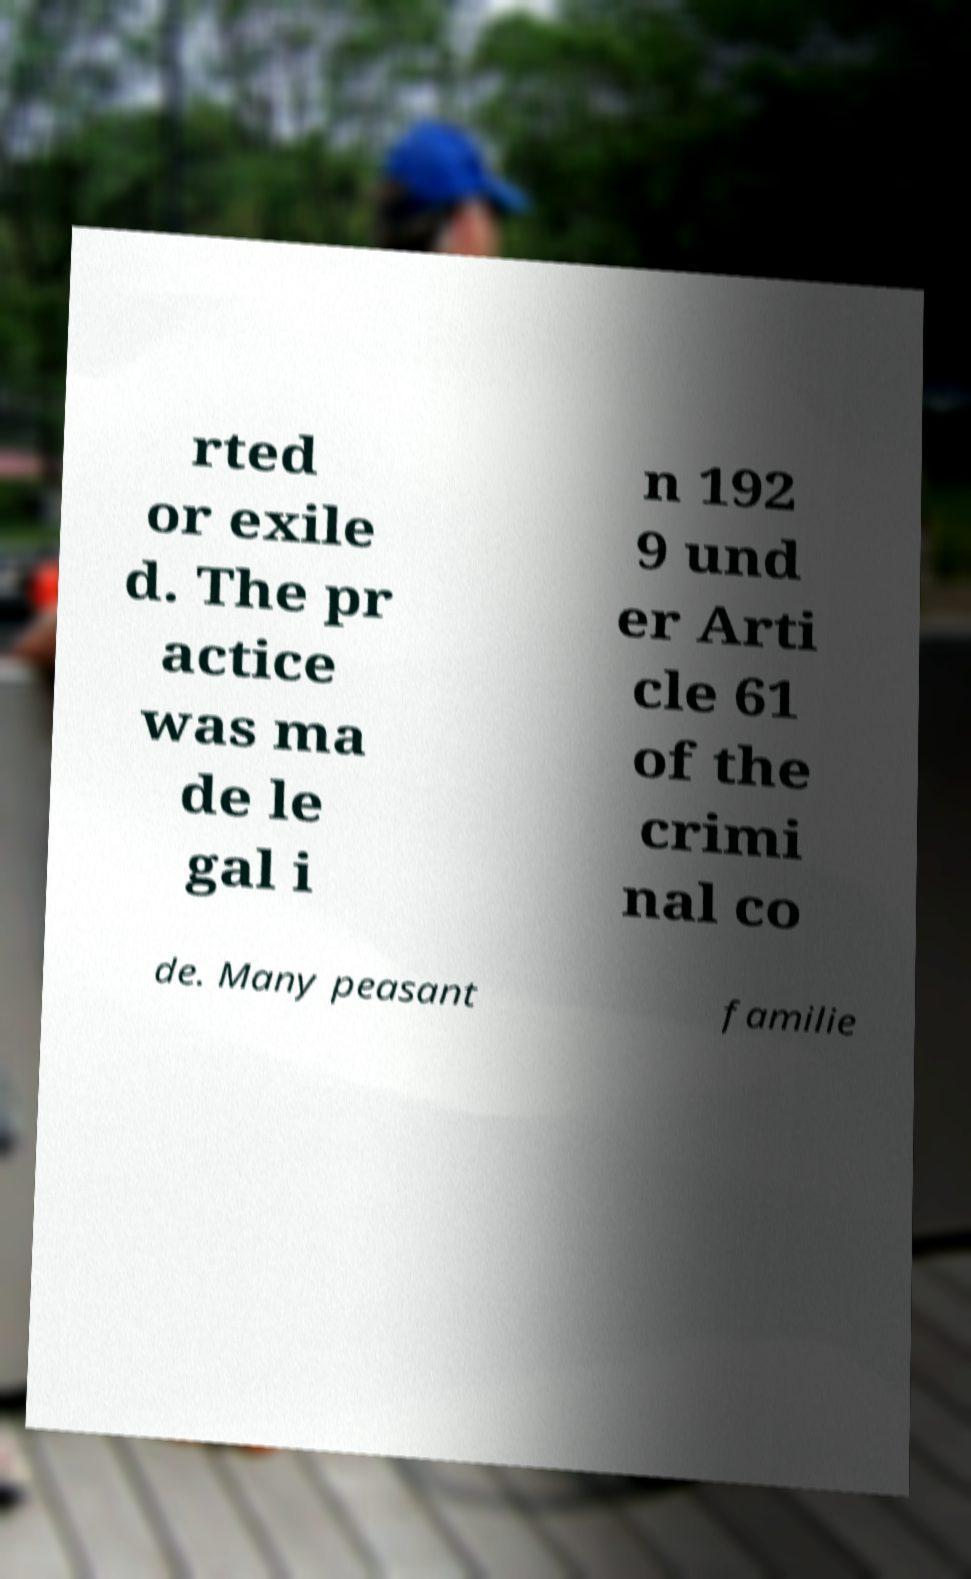I need the written content from this picture converted into text. Can you do that? rted or exile d. The pr actice was ma de le gal i n 192 9 und er Arti cle 61 of the crimi nal co de. Many peasant familie 